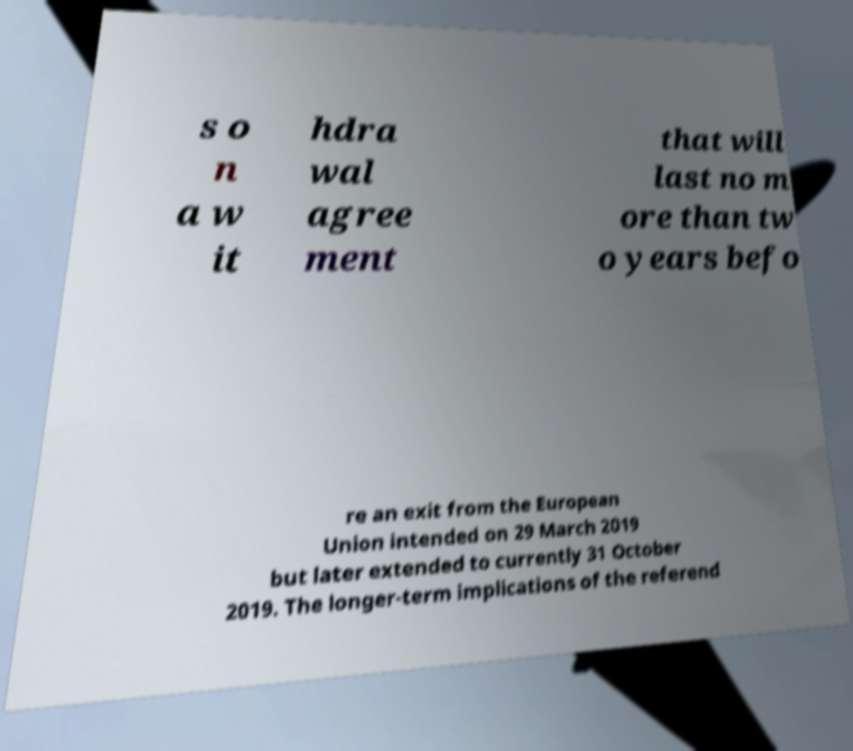Please identify and transcribe the text found in this image. s o n a w it hdra wal agree ment that will last no m ore than tw o years befo re an exit from the European Union intended on 29 March 2019 but later extended to currently 31 October 2019. The longer-term implications of the referend 